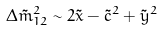Convert formula to latex. <formula><loc_0><loc_0><loc_500><loc_500>\Delta \tilde { m } ^ { 2 } _ { 1 2 } \sim 2 \tilde { x } - \tilde { c } ^ { 2 } + \tilde { y } ^ { 2 }</formula> 